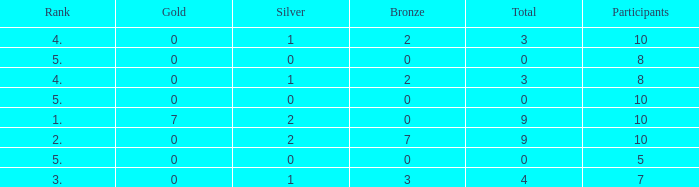What is listed as the highest Rank that has a Gold that's larger than 0, and Participants that's smaller than 10? None. 